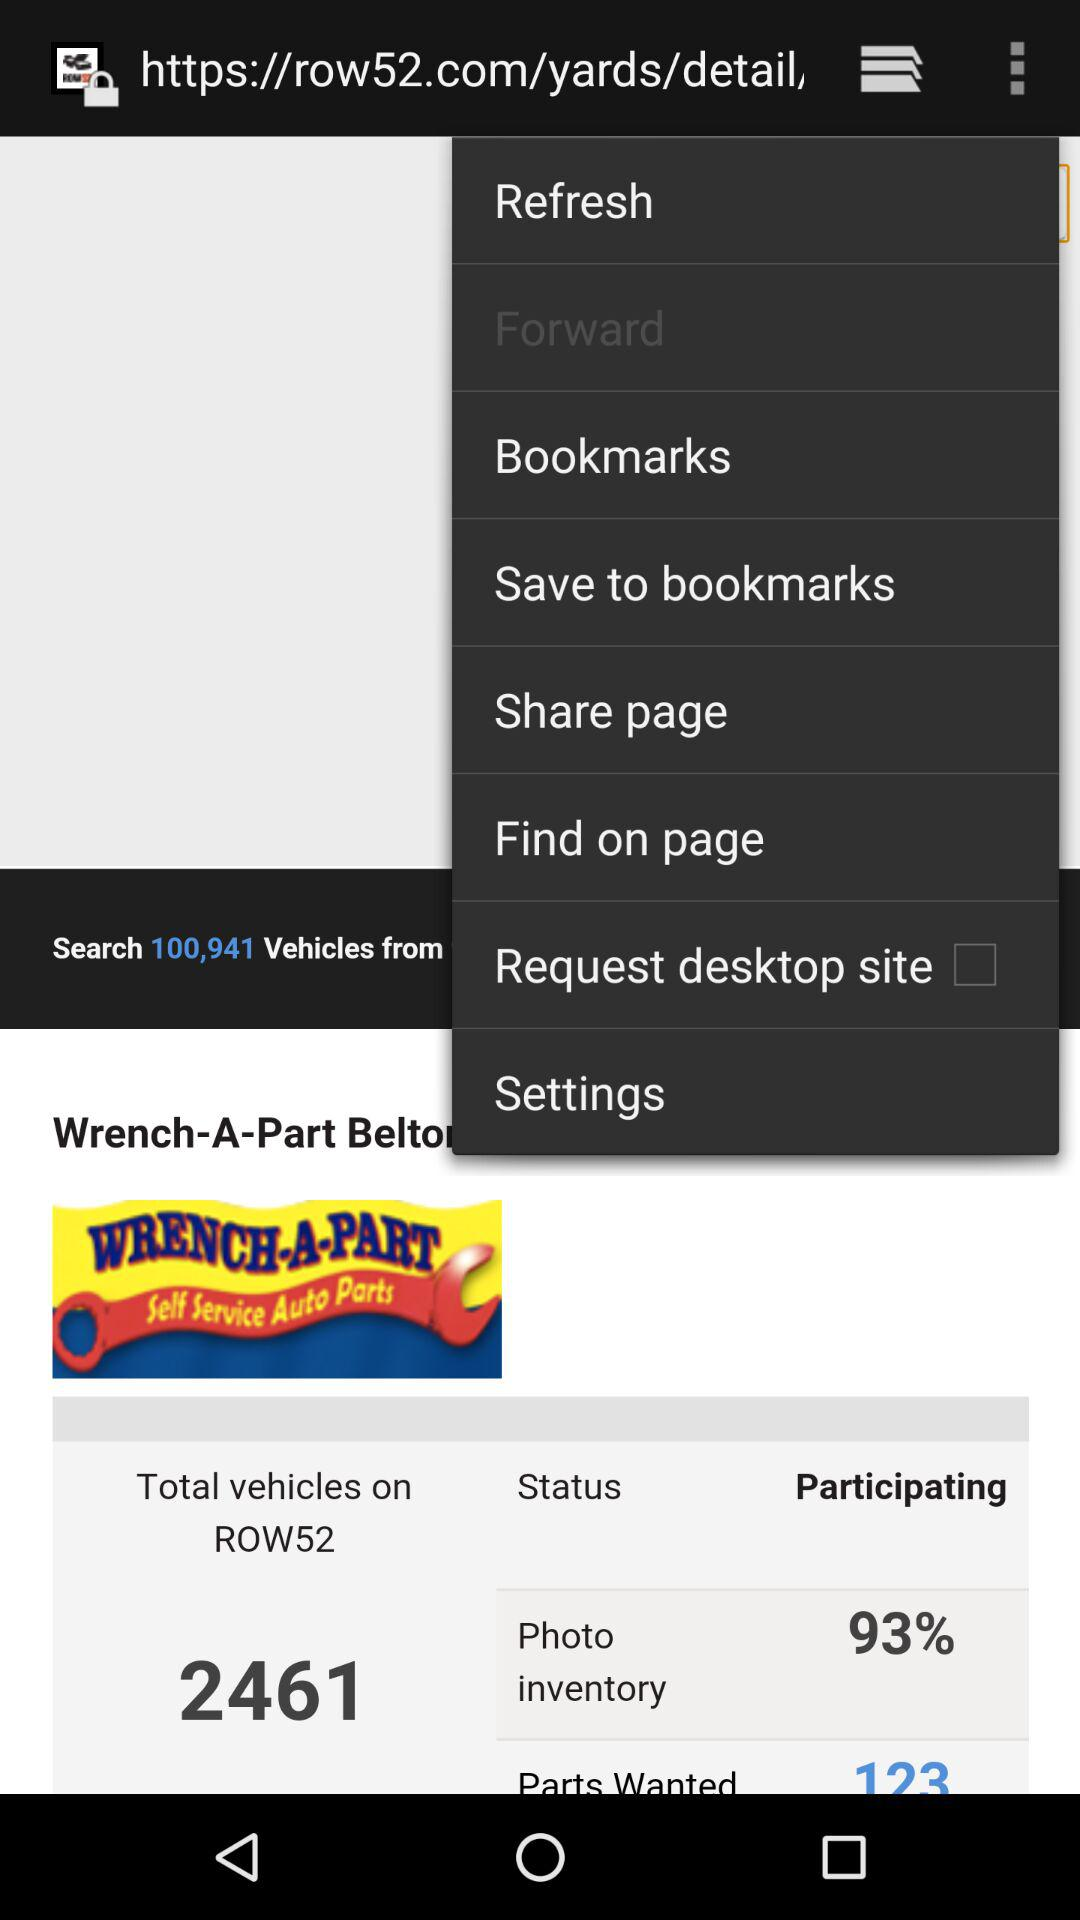What is the number mentioned for "Parts Wanted"? The number mentioned for "Parts Wanted" is 123. 